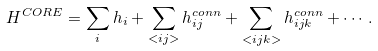<formula> <loc_0><loc_0><loc_500><loc_500>H ^ { C O R E } = \sum _ { i } h _ { i } + \sum _ { < i j > } h _ { i j } ^ { c o n n } + \sum _ { < i j k > } h _ { i j k } ^ { c o n n } + \cdots .</formula> 